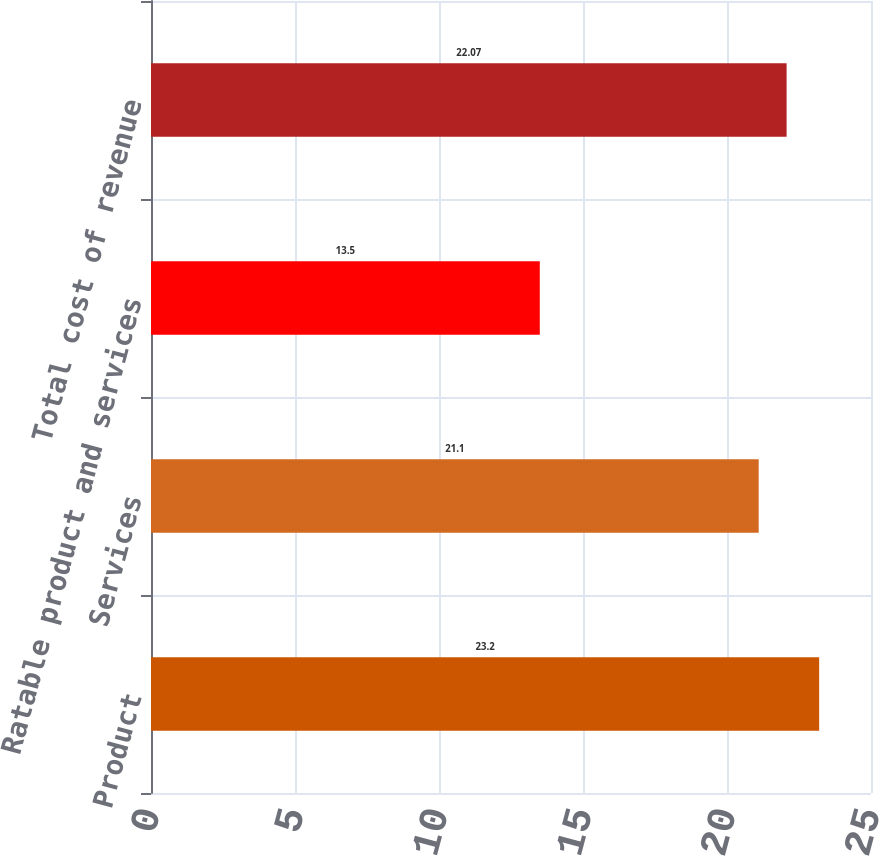<chart> <loc_0><loc_0><loc_500><loc_500><bar_chart><fcel>Product<fcel>Services<fcel>Ratable product and services<fcel>Total cost of revenue<nl><fcel>23.2<fcel>21.1<fcel>13.5<fcel>22.07<nl></chart> 